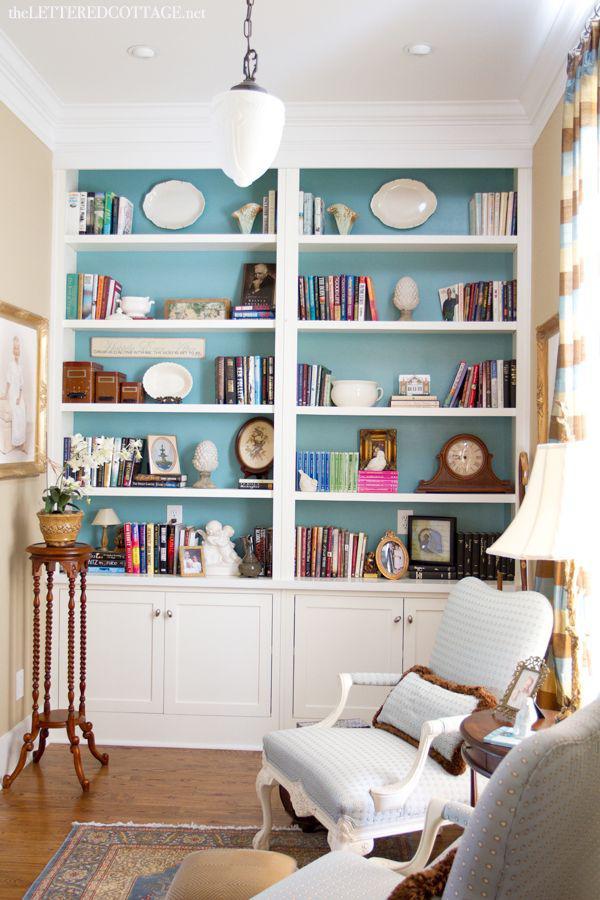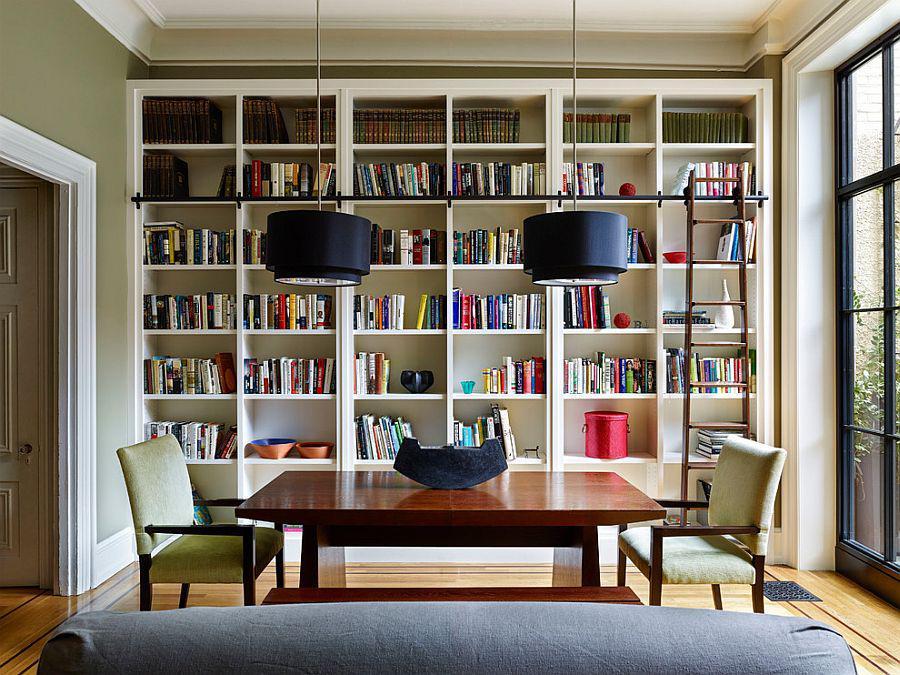The first image is the image on the left, the second image is the image on the right. Analyze the images presented: Is the assertion "A bookshelf sits behind a dark colored couch in the image on the right." valid? Answer yes or no. No. 